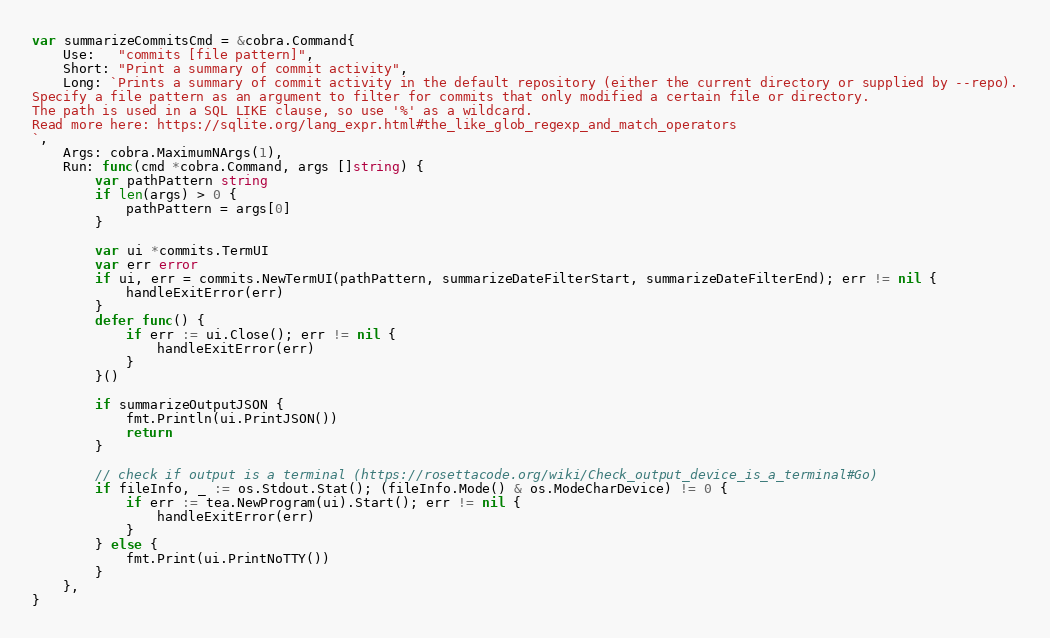Convert code to text. <code><loc_0><loc_0><loc_500><loc_500><_Go_>
var summarizeCommitsCmd = &cobra.Command{
	Use:   "commits [file pattern]",
	Short: "Print a summary of commit activity",
	Long: `Prints a summary of commit activity in the default repository (either the current directory or supplied by --repo).
Specify a file pattern as an argument to filter for commits that only modified a certain file or directory.
The path is used in a SQL LIKE clause, so use '%' as a wildcard.
Read more here: https://sqlite.org/lang_expr.html#the_like_glob_regexp_and_match_operators
`,
	Args: cobra.MaximumNArgs(1),
	Run: func(cmd *cobra.Command, args []string) {
		var pathPattern string
		if len(args) > 0 {
			pathPattern = args[0]
		}

		var ui *commits.TermUI
		var err error
		if ui, err = commits.NewTermUI(pathPattern, summarizeDateFilterStart, summarizeDateFilterEnd); err != nil {
			handleExitError(err)
		}
		defer func() {
			if err := ui.Close(); err != nil {
				handleExitError(err)
			}
		}()

		if summarizeOutputJSON {
			fmt.Println(ui.PrintJSON())
			return
		}

		// check if output is a terminal (https://rosettacode.org/wiki/Check_output_device_is_a_terminal#Go)
		if fileInfo, _ := os.Stdout.Stat(); (fileInfo.Mode() & os.ModeCharDevice) != 0 {
			if err := tea.NewProgram(ui).Start(); err != nil {
				handleExitError(err)
			}
		} else {
			fmt.Print(ui.PrintNoTTY())
		}
	},
}
</code> 